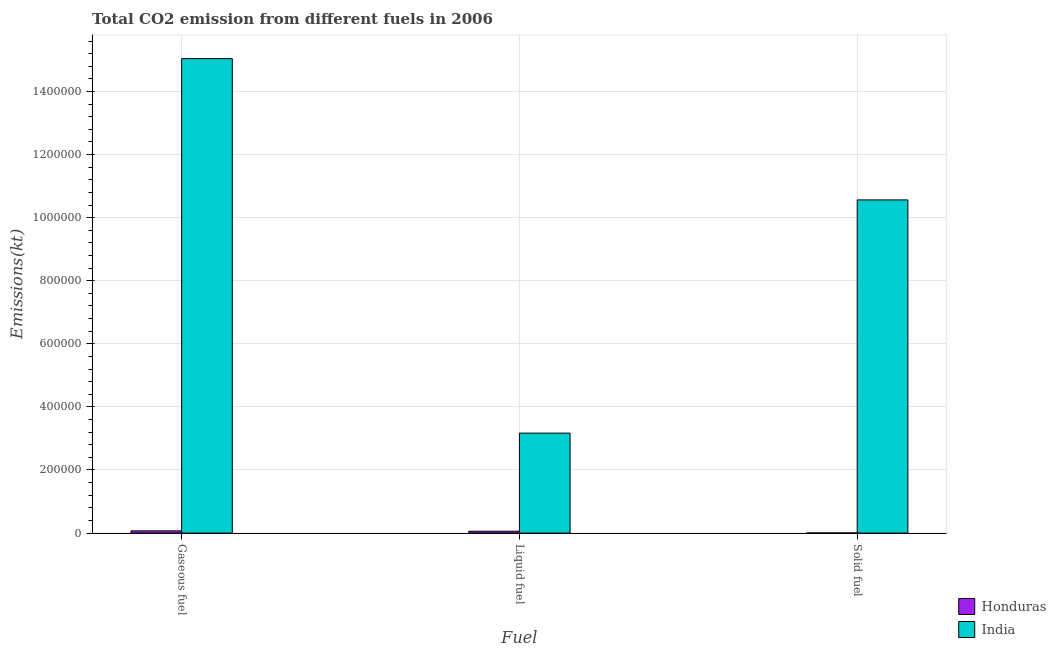How many different coloured bars are there?
Offer a terse response. 2. Are the number of bars per tick equal to the number of legend labels?
Provide a short and direct response. Yes. Are the number of bars on each tick of the X-axis equal?
Keep it short and to the point. Yes. What is the label of the 1st group of bars from the left?
Ensure brevity in your answer.  Gaseous fuel. What is the amount of co2 emissions from solid fuel in India?
Your answer should be compact. 1.06e+06. Across all countries, what is the maximum amount of co2 emissions from liquid fuel?
Provide a succinct answer. 3.17e+05. Across all countries, what is the minimum amount of co2 emissions from solid fuel?
Offer a terse response. 330.03. In which country was the amount of co2 emissions from liquid fuel minimum?
Provide a short and direct response. Honduras. What is the total amount of co2 emissions from gaseous fuel in the graph?
Your response must be concise. 1.51e+06. What is the difference between the amount of co2 emissions from gaseous fuel in Honduras and that in India?
Your answer should be very brief. -1.50e+06. What is the difference between the amount of co2 emissions from gaseous fuel in India and the amount of co2 emissions from liquid fuel in Honduras?
Ensure brevity in your answer.  1.50e+06. What is the average amount of co2 emissions from gaseous fuel per country?
Provide a short and direct response. 7.56e+05. What is the difference between the amount of co2 emissions from solid fuel and amount of co2 emissions from gaseous fuel in Honduras?
Your response must be concise. -6677.61. What is the ratio of the amount of co2 emissions from solid fuel in India to that in Honduras?
Offer a terse response. 3200.77. Is the difference between the amount of co2 emissions from gaseous fuel in Honduras and India greater than the difference between the amount of co2 emissions from liquid fuel in Honduras and India?
Your answer should be compact. No. What is the difference between the highest and the second highest amount of co2 emissions from gaseous fuel?
Your answer should be very brief. 1.50e+06. What is the difference between the highest and the lowest amount of co2 emissions from solid fuel?
Give a very brief answer. 1.06e+06. In how many countries, is the amount of co2 emissions from solid fuel greater than the average amount of co2 emissions from solid fuel taken over all countries?
Keep it short and to the point. 1. Is the sum of the amount of co2 emissions from solid fuel in Honduras and India greater than the maximum amount of co2 emissions from liquid fuel across all countries?
Your answer should be compact. Yes. What does the 2nd bar from the left in Gaseous fuel represents?
Your response must be concise. India. What does the 2nd bar from the right in Solid fuel represents?
Make the answer very short. Honduras. Is it the case that in every country, the sum of the amount of co2 emissions from gaseous fuel and amount of co2 emissions from liquid fuel is greater than the amount of co2 emissions from solid fuel?
Your response must be concise. Yes. What is the difference between two consecutive major ticks on the Y-axis?
Keep it short and to the point. 2.00e+05. Are the values on the major ticks of Y-axis written in scientific E-notation?
Offer a terse response. No. What is the title of the graph?
Give a very brief answer. Total CO2 emission from different fuels in 2006. What is the label or title of the X-axis?
Your answer should be very brief. Fuel. What is the label or title of the Y-axis?
Provide a short and direct response. Emissions(kt). What is the Emissions(kt) in Honduras in Gaseous fuel?
Give a very brief answer. 7007.64. What is the Emissions(kt) of India in Gaseous fuel?
Your answer should be compact. 1.50e+06. What is the Emissions(kt) of Honduras in Liquid fuel?
Your response must be concise. 5845.2. What is the Emissions(kt) of India in Liquid fuel?
Your answer should be compact. 3.17e+05. What is the Emissions(kt) in Honduras in Solid fuel?
Make the answer very short. 330.03. What is the Emissions(kt) of India in Solid fuel?
Provide a short and direct response. 1.06e+06. Across all Fuel, what is the maximum Emissions(kt) in Honduras?
Your answer should be compact. 7007.64. Across all Fuel, what is the maximum Emissions(kt) of India?
Your answer should be very brief. 1.50e+06. Across all Fuel, what is the minimum Emissions(kt) of Honduras?
Give a very brief answer. 330.03. Across all Fuel, what is the minimum Emissions(kt) in India?
Provide a short and direct response. 3.17e+05. What is the total Emissions(kt) of Honduras in the graph?
Keep it short and to the point. 1.32e+04. What is the total Emissions(kt) of India in the graph?
Provide a succinct answer. 2.88e+06. What is the difference between the Emissions(kt) in Honduras in Gaseous fuel and that in Liquid fuel?
Your answer should be very brief. 1162.44. What is the difference between the Emissions(kt) of India in Gaseous fuel and that in Liquid fuel?
Provide a short and direct response. 1.19e+06. What is the difference between the Emissions(kt) in Honduras in Gaseous fuel and that in Solid fuel?
Make the answer very short. 6677.61. What is the difference between the Emissions(kt) of India in Gaseous fuel and that in Solid fuel?
Make the answer very short. 4.48e+05. What is the difference between the Emissions(kt) of Honduras in Liquid fuel and that in Solid fuel?
Offer a very short reply. 5515.17. What is the difference between the Emissions(kt) in India in Liquid fuel and that in Solid fuel?
Ensure brevity in your answer.  -7.39e+05. What is the difference between the Emissions(kt) in Honduras in Gaseous fuel and the Emissions(kt) in India in Liquid fuel?
Give a very brief answer. -3.10e+05. What is the difference between the Emissions(kt) of Honduras in Gaseous fuel and the Emissions(kt) of India in Solid fuel?
Your response must be concise. -1.05e+06. What is the difference between the Emissions(kt) in Honduras in Liquid fuel and the Emissions(kt) in India in Solid fuel?
Provide a short and direct response. -1.05e+06. What is the average Emissions(kt) in Honduras per Fuel?
Your answer should be compact. 4394.29. What is the average Emissions(kt) of India per Fuel?
Ensure brevity in your answer.  9.59e+05. What is the difference between the Emissions(kt) of Honduras and Emissions(kt) of India in Gaseous fuel?
Your response must be concise. -1.50e+06. What is the difference between the Emissions(kt) in Honduras and Emissions(kt) in India in Liquid fuel?
Offer a very short reply. -3.11e+05. What is the difference between the Emissions(kt) of Honduras and Emissions(kt) of India in Solid fuel?
Your answer should be compact. -1.06e+06. What is the ratio of the Emissions(kt) of Honduras in Gaseous fuel to that in Liquid fuel?
Your answer should be compact. 1.2. What is the ratio of the Emissions(kt) of India in Gaseous fuel to that in Liquid fuel?
Make the answer very short. 4.75. What is the ratio of the Emissions(kt) of Honduras in Gaseous fuel to that in Solid fuel?
Your answer should be compact. 21.23. What is the ratio of the Emissions(kt) in India in Gaseous fuel to that in Solid fuel?
Offer a very short reply. 1.42. What is the ratio of the Emissions(kt) of Honduras in Liquid fuel to that in Solid fuel?
Provide a succinct answer. 17.71. What is the difference between the highest and the second highest Emissions(kt) in Honduras?
Provide a short and direct response. 1162.44. What is the difference between the highest and the second highest Emissions(kt) of India?
Give a very brief answer. 4.48e+05. What is the difference between the highest and the lowest Emissions(kt) in Honduras?
Your answer should be very brief. 6677.61. What is the difference between the highest and the lowest Emissions(kt) in India?
Make the answer very short. 1.19e+06. 